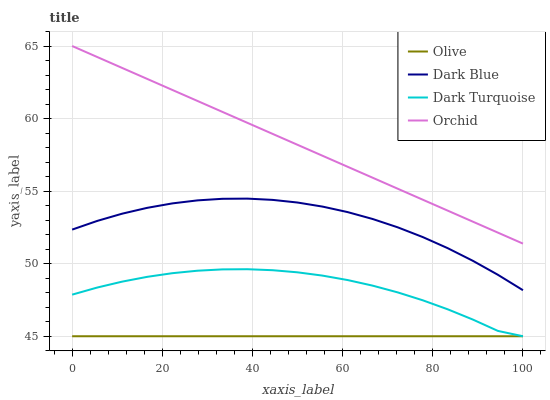Does Olive have the minimum area under the curve?
Answer yes or no. Yes. Does Orchid have the maximum area under the curve?
Answer yes or no. Yes. Does Dark Blue have the minimum area under the curve?
Answer yes or no. No. Does Dark Blue have the maximum area under the curve?
Answer yes or no. No. Is Olive the smoothest?
Answer yes or no. Yes. Is Dark Turquoise the roughest?
Answer yes or no. Yes. Is Dark Blue the smoothest?
Answer yes or no. No. Is Dark Blue the roughest?
Answer yes or no. No. Does Olive have the lowest value?
Answer yes or no. Yes. Does Dark Blue have the lowest value?
Answer yes or no. No. Does Orchid have the highest value?
Answer yes or no. Yes. Does Dark Blue have the highest value?
Answer yes or no. No. Is Dark Turquoise less than Dark Blue?
Answer yes or no. Yes. Is Orchid greater than Dark Turquoise?
Answer yes or no. Yes. Does Olive intersect Dark Turquoise?
Answer yes or no. Yes. Is Olive less than Dark Turquoise?
Answer yes or no. No. Is Olive greater than Dark Turquoise?
Answer yes or no. No. Does Dark Turquoise intersect Dark Blue?
Answer yes or no. No. 